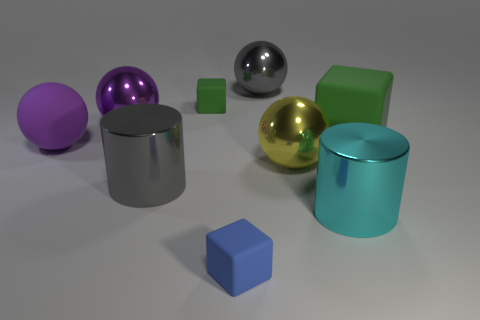Subtract all gray metal balls. How many balls are left? 3 Subtract all gray balls. How many balls are left? 3 Subtract all cylinders. How many objects are left? 7 Subtract 1 cubes. How many cubes are left? 2 Subtract all green cylinders. Subtract all green balls. How many cylinders are left? 2 Subtract all cyan spheres. How many cyan blocks are left? 0 Subtract all red metal balls. Subtract all tiny blue things. How many objects are left? 8 Add 1 cyan metal cylinders. How many cyan metal cylinders are left? 2 Add 2 cyan metallic objects. How many cyan metallic objects exist? 3 Subtract 0 red balls. How many objects are left? 9 